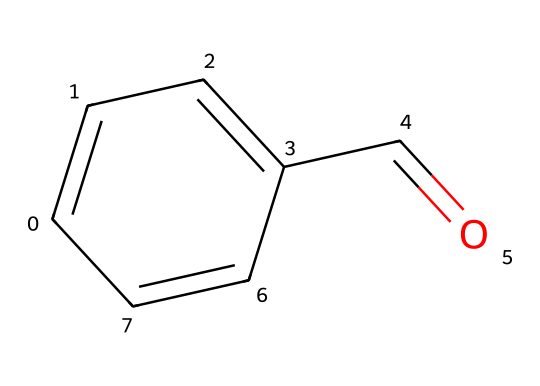What is the molecular formula of benzaldehyde? The given SMILES corresponds to a compound comprised of carbon, hydrogen, and oxygen. By analyzing the SMILES, we can deduce that there are 7 carbon atoms, 6 hydrogen atoms, and 1 oxygen atom, leading to the molecular formula C7H6O.
Answer: C7H6O How many carbon atoms are present in benzaldehyde? The SMILES shows a total of 7 carbon atoms, derived from counting the 'C' characters, indicating the structure has 7 individual carbon units.
Answer: 7 Does benzaldehyde contain a double bond? The structure indicates the presence of double bonds between carbon atoms, specifically in the aromatic ring and the carbonyl group (C=O), therefore confirming the existence of double bonds.
Answer: Yes What type of functional group is present in benzaldehyde? The structural formula indicates a carbonyl group (C=O) attached to the aromatic ring, classifying it as an aldehyde functional group. Since it is at the end of a carbon chain directly attached to the benzene, it confirms its aldehyde classification.
Answer: Aldehyde What does the presence of the aromatic ring signify about benzaldehyde? The aromatic ring's structure provides stability and unique properties like distinct aromas and reactivity, common to aromatic compounds. The ring allows for resonance stabilization and contributes to the compound's character.
Answer: Stability What is the key characteristic of the aroma of benzaldehyde? Benzaldehyde's structure, particularly the aromatic ring and carbonyl group, is responsible for its almond-like aroma, which is a defining characteristic of this compound, making it notable in the culinary field.
Answer: Almond-like aroma 